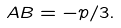Convert formula to latex. <formula><loc_0><loc_0><loc_500><loc_500>A B = - p / 3 .</formula> 